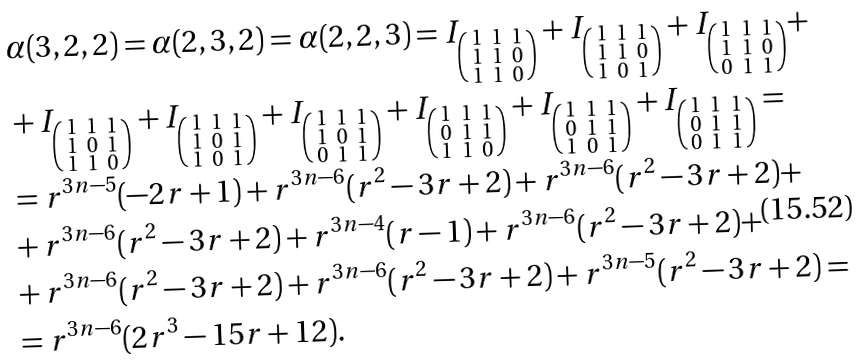<formula> <loc_0><loc_0><loc_500><loc_500>& \alpha ( 3 , 2 , 2 ) = \alpha ( 2 , 3 , 2 ) = \alpha ( 2 , 2 , 3 ) = I _ { \left ( \begin{smallmatrix} 1 & 1 & 1 \\ 1 & 1 & 0 \\ 1 & 1 & 0 \end{smallmatrix} \right ) } + I _ { \left ( \begin{smallmatrix} 1 & 1 & 1 \\ 1 & 1 & 0 \\ 1 & 0 & 1 \end{smallmatrix} \right ) } + I _ { \left ( \begin{smallmatrix} 1 & 1 & 1 \\ 1 & 1 & 0 \\ 0 & 1 & 1 \end{smallmatrix} \right ) } + \\ & + I _ { \left ( \begin{smallmatrix} 1 & 1 & 1 \\ 1 & 0 & 1 \\ 1 & 1 & 0 \end{smallmatrix} \right ) } + I _ { \left ( \begin{smallmatrix} 1 & 1 & 1 \\ 1 & 0 & 1 \\ 1 & 0 & 1 \end{smallmatrix} \right ) } + I _ { \left ( \begin{smallmatrix} 1 & 1 & 1 \\ 1 & 0 & 1 \\ 0 & 1 & 1 \end{smallmatrix} \right ) } + I _ { \left ( \begin{smallmatrix} 1 & 1 & 1 \\ 0 & 1 & 1 \\ 1 & 1 & 0 \end{smallmatrix} \right ) } + I _ { \left ( \begin{smallmatrix} 1 & 1 & 1 \\ 0 & 1 & 1 \\ 1 & 0 & 1 \end{smallmatrix} \right ) } + I _ { \left ( \begin{smallmatrix} 1 & 1 & 1 \\ 0 & 1 & 1 \\ 0 & 1 & 1 \end{smallmatrix} \right ) } = \\ & = r ^ { 3 n - 5 } ( - 2 r + 1 ) + r ^ { 3 n - 6 } ( r ^ { 2 } - 3 r + 2 ) + r ^ { 3 n - 6 } ( r ^ { 2 } - 3 r + 2 ) + \\ & + r ^ { 3 n - 6 } ( r ^ { 2 } - 3 r + 2 ) + r ^ { 3 n - 4 } ( r - 1 ) + r ^ { 3 n - 6 } ( r ^ { 2 } - 3 r + 2 ) + \\ & + r ^ { 3 n - 6 } ( r ^ { 2 } - 3 r + 2 ) + r ^ { 3 n - 6 } ( r ^ { 2 } - 3 r + 2 ) + r ^ { 3 n - 5 } ( r ^ { 2 } - 3 r + 2 ) = \\ & = r ^ { 3 n - 6 } ( 2 r ^ { 3 } - 1 5 r + 1 2 ) .</formula> 